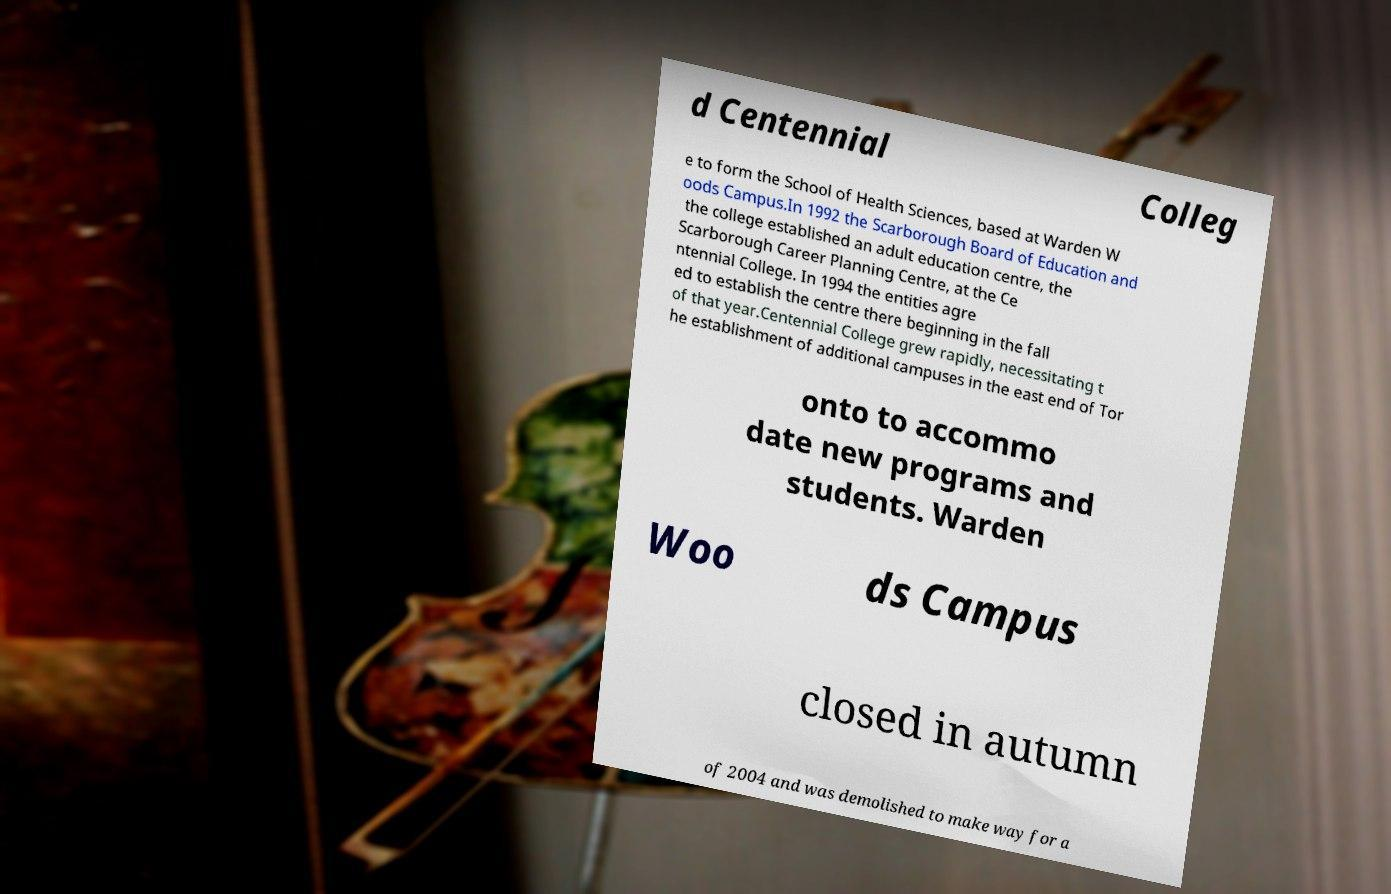Can you accurately transcribe the text from the provided image for me? d Centennial Colleg e to form the School of Health Sciences, based at Warden W oods Campus.In 1992 the Scarborough Board of Education and the college established an adult education centre, the Scarborough Career Planning Centre, at the Ce ntennial College. In 1994 the entities agre ed to establish the centre there beginning in the fall of that year.Centennial College grew rapidly, necessitating t he establishment of additional campuses in the east end of Tor onto to accommo date new programs and students. Warden Woo ds Campus closed in autumn of 2004 and was demolished to make way for a 